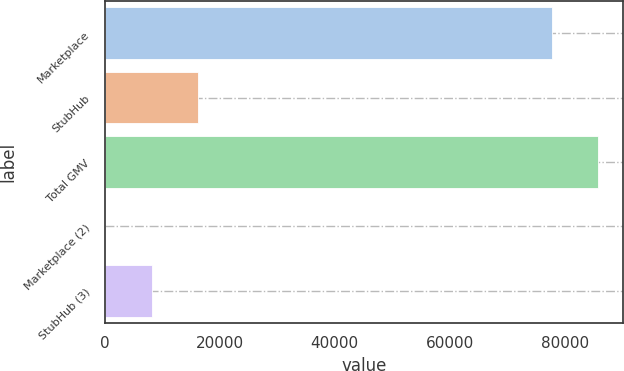Convert chart. <chart><loc_0><loc_0><loc_500><loc_500><bar_chart><fcel>Marketplace<fcel>StubHub<fcel>Total GMV<fcel>Marketplace (2)<fcel>StubHub (3)<nl><fcel>77729<fcel>16267.1<fcel>85858.6<fcel>7.85<fcel>8137.47<nl></chart> 